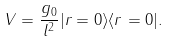<formula> <loc_0><loc_0><loc_500><loc_500>V = \frac { g _ { 0 } } { l ^ { 2 } } | { r } = 0 \rangle \langle { r } = 0 | .</formula> 